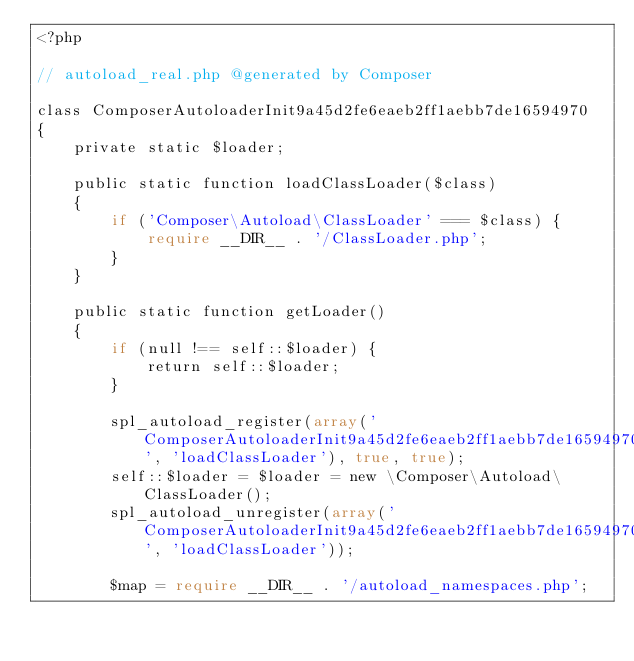<code> <loc_0><loc_0><loc_500><loc_500><_PHP_><?php

// autoload_real.php @generated by Composer

class ComposerAutoloaderInit9a45d2fe6eaeb2ff1aebb7de16594970
{
    private static $loader;

    public static function loadClassLoader($class)
    {
        if ('Composer\Autoload\ClassLoader' === $class) {
            require __DIR__ . '/ClassLoader.php';
        }
    }

    public static function getLoader()
    {
        if (null !== self::$loader) {
            return self::$loader;
        }

        spl_autoload_register(array('ComposerAutoloaderInit9a45d2fe6eaeb2ff1aebb7de16594970', 'loadClassLoader'), true, true);
        self::$loader = $loader = new \Composer\Autoload\ClassLoader();
        spl_autoload_unregister(array('ComposerAutoloaderInit9a45d2fe6eaeb2ff1aebb7de16594970', 'loadClassLoader'));

        $map = require __DIR__ . '/autoload_namespaces.php';</code> 